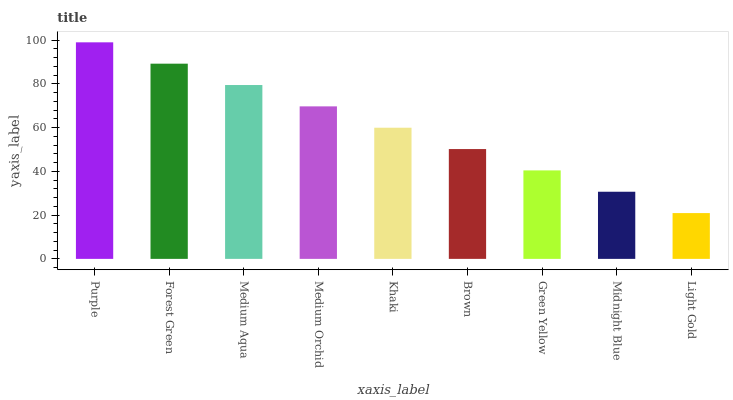Is Forest Green the minimum?
Answer yes or no. No. Is Forest Green the maximum?
Answer yes or no. No. Is Purple greater than Forest Green?
Answer yes or no. Yes. Is Forest Green less than Purple?
Answer yes or no. Yes. Is Forest Green greater than Purple?
Answer yes or no. No. Is Purple less than Forest Green?
Answer yes or no. No. Is Khaki the high median?
Answer yes or no. Yes. Is Khaki the low median?
Answer yes or no. Yes. Is Midnight Blue the high median?
Answer yes or no. No. Is Forest Green the low median?
Answer yes or no. No. 